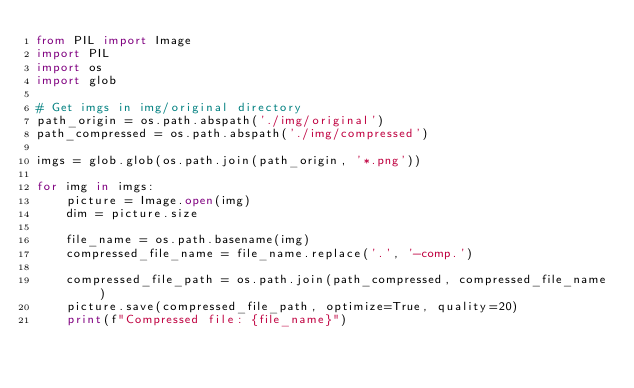Convert code to text. <code><loc_0><loc_0><loc_500><loc_500><_Python_>from PIL import Image
import PIL
import os
import glob

# Get imgs in img/original directory
path_origin = os.path.abspath('./img/original')
path_compressed = os.path.abspath('./img/compressed')

imgs = glob.glob(os.path.join(path_origin, '*.png'))

for img in imgs:
    picture = Image.open(img)
    dim = picture.size

    file_name = os.path.basename(img)
    compressed_file_name = file_name.replace('.', '-comp.')

    compressed_file_path = os.path.join(path_compressed, compressed_file_name)
    picture.save(compressed_file_path, optimize=True, quality=20)
    print(f"Compressed file: {file_name}")
</code> 